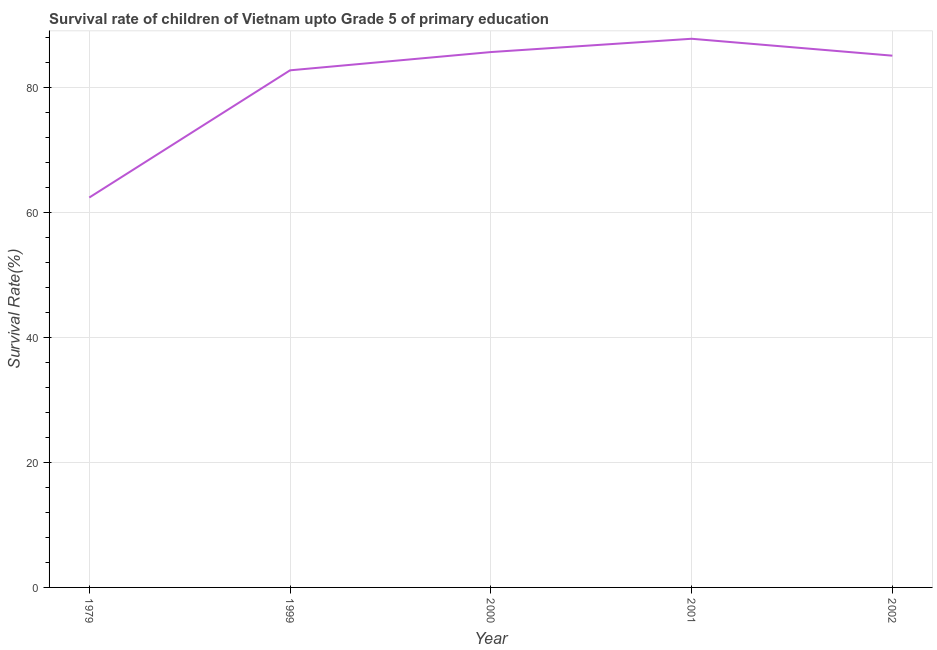What is the survival rate in 1999?
Give a very brief answer. 82.82. Across all years, what is the maximum survival rate?
Keep it short and to the point. 87.87. Across all years, what is the minimum survival rate?
Your answer should be compact. 62.44. In which year was the survival rate maximum?
Your answer should be compact. 2001. In which year was the survival rate minimum?
Offer a very short reply. 1979. What is the sum of the survival rate?
Offer a very short reply. 404.04. What is the difference between the survival rate in 1979 and 2002?
Your response must be concise. -22.72. What is the average survival rate per year?
Provide a short and direct response. 80.81. What is the median survival rate?
Offer a very short reply. 85.17. What is the ratio of the survival rate in 1999 to that in 2001?
Make the answer very short. 0.94. Is the survival rate in 1979 less than that in 2001?
Make the answer very short. Yes. Is the difference between the survival rate in 1979 and 1999 greater than the difference between any two years?
Offer a terse response. No. What is the difference between the highest and the second highest survival rate?
Ensure brevity in your answer.  2.13. What is the difference between the highest and the lowest survival rate?
Make the answer very short. 25.43. How many lines are there?
Ensure brevity in your answer.  1. How many years are there in the graph?
Provide a short and direct response. 5. What is the difference between two consecutive major ticks on the Y-axis?
Provide a short and direct response. 20. Are the values on the major ticks of Y-axis written in scientific E-notation?
Your response must be concise. No. Does the graph contain any zero values?
Make the answer very short. No. Does the graph contain grids?
Offer a terse response. Yes. What is the title of the graph?
Make the answer very short. Survival rate of children of Vietnam upto Grade 5 of primary education. What is the label or title of the Y-axis?
Keep it short and to the point. Survival Rate(%). What is the Survival Rate(%) of 1979?
Provide a succinct answer. 62.44. What is the Survival Rate(%) of 1999?
Ensure brevity in your answer.  82.82. What is the Survival Rate(%) in 2000?
Your answer should be compact. 85.74. What is the Survival Rate(%) of 2001?
Make the answer very short. 87.87. What is the Survival Rate(%) in 2002?
Your answer should be very brief. 85.17. What is the difference between the Survival Rate(%) in 1979 and 1999?
Offer a terse response. -20.38. What is the difference between the Survival Rate(%) in 1979 and 2000?
Ensure brevity in your answer.  -23.3. What is the difference between the Survival Rate(%) in 1979 and 2001?
Give a very brief answer. -25.43. What is the difference between the Survival Rate(%) in 1979 and 2002?
Your response must be concise. -22.72. What is the difference between the Survival Rate(%) in 1999 and 2000?
Make the answer very short. -2.92. What is the difference between the Survival Rate(%) in 1999 and 2001?
Offer a terse response. -5.05. What is the difference between the Survival Rate(%) in 1999 and 2002?
Your answer should be compact. -2.35. What is the difference between the Survival Rate(%) in 2000 and 2001?
Give a very brief answer. -2.13. What is the difference between the Survival Rate(%) in 2000 and 2002?
Keep it short and to the point. 0.58. What is the difference between the Survival Rate(%) in 2001 and 2002?
Offer a very short reply. 2.71. What is the ratio of the Survival Rate(%) in 1979 to that in 1999?
Your answer should be very brief. 0.75. What is the ratio of the Survival Rate(%) in 1979 to that in 2000?
Ensure brevity in your answer.  0.73. What is the ratio of the Survival Rate(%) in 1979 to that in 2001?
Provide a short and direct response. 0.71. What is the ratio of the Survival Rate(%) in 1979 to that in 2002?
Give a very brief answer. 0.73. What is the ratio of the Survival Rate(%) in 1999 to that in 2000?
Offer a very short reply. 0.97. What is the ratio of the Survival Rate(%) in 1999 to that in 2001?
Provide a succinct answer. 0.94. What is the ratio of the Survival Rate(%) in 2001 to that in 2002?
Your answer should be very brief. 1.03. 